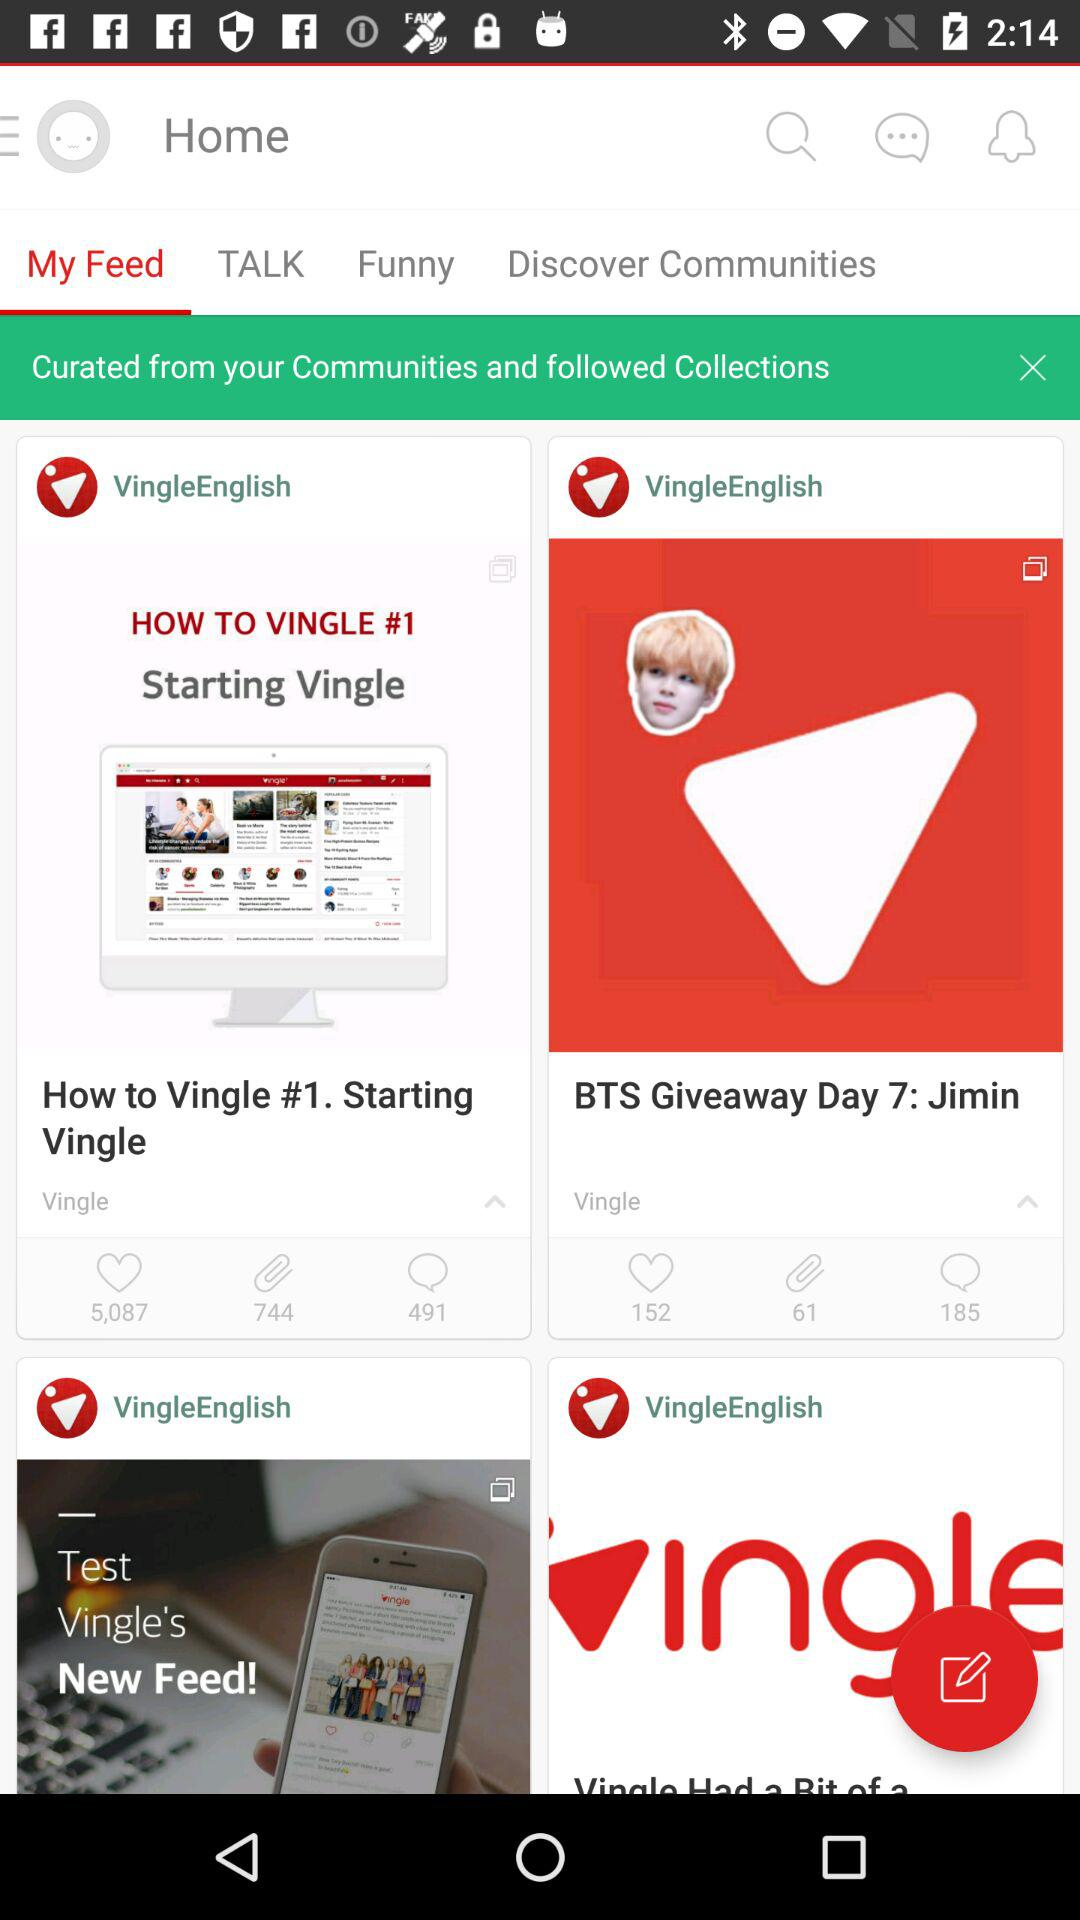What is the number of likes that "How to Vingle #1. Starting Vingle" has gotten? The number of likes is 5,087. 